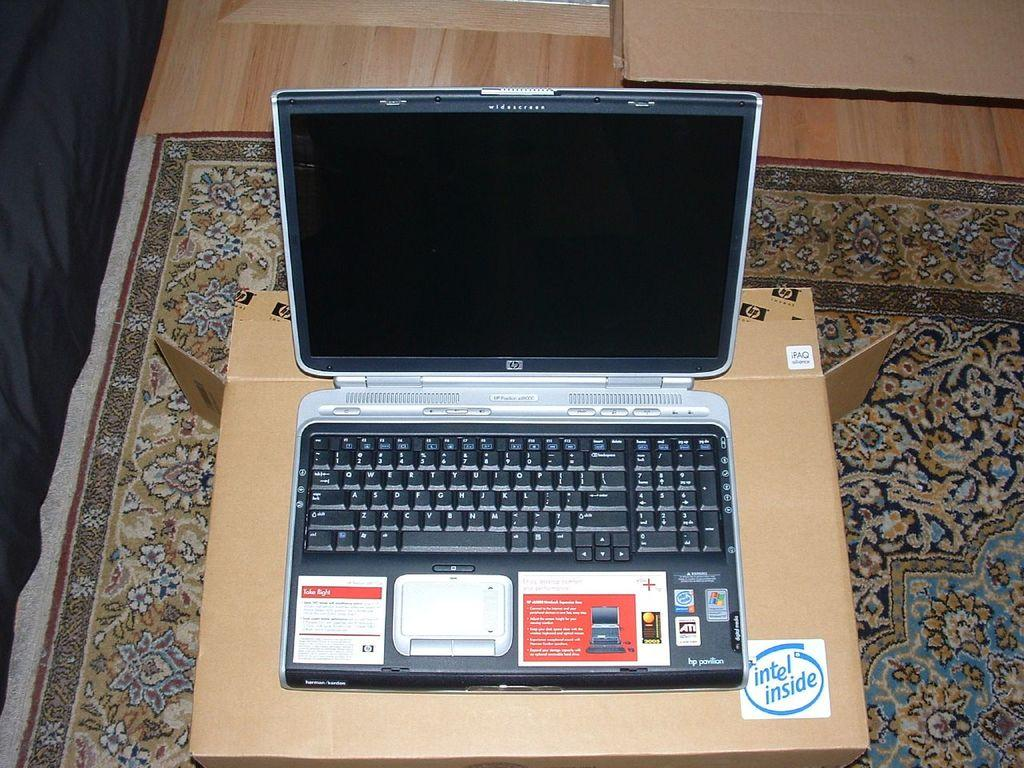Provide a one-sentence caption for the provided image. A HP laptop is sitting on a cardboard box that has an intel inside sticker on it. 